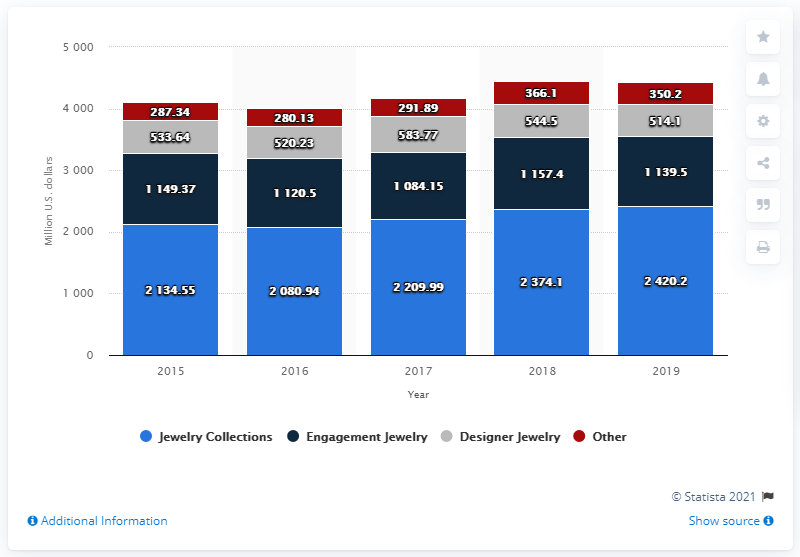Identify some key points in this picture. In 2019, the net sales of Tiffany & Co.'s fashion jewelry segment were $2420.2 million. 